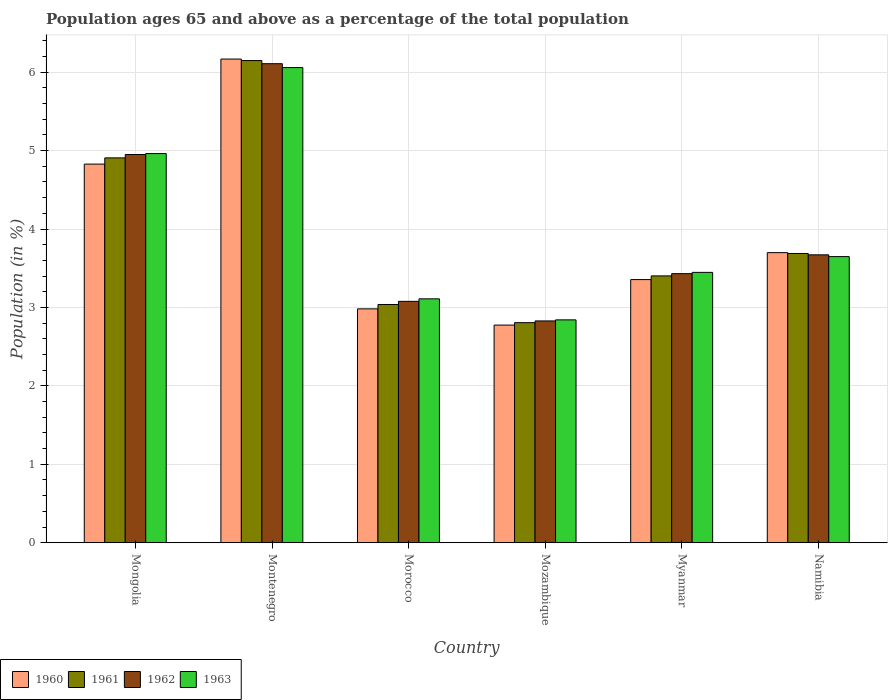How many different coloured bars are there?
Offer a terse response. 4. Are the number of bars per tick equal to the number of legend labels?
Provide a succinct answer. Yes. Are the number of bars on each tick of the X-axis equal?
Keep it short and to the point. Yes. How many bars are there on the 5th tick from the left?
Keep it short and to the point. 4. What is the label of the 6th group of bars from the left?
Ensure brevity in your answer.  Namibia. In how many cases, is the number of bars for a given country not equal to the number of legend labels?
Your answer should be very brief. 0. What is the percentage of the population ages 65 and above in 1962 in Namibia?
Your answer should be very brief. 3.67. Across all countries, what is the maximum percentage of the population ages 65 and above in 1961?
Give a very brief answer. 6.15. Across all countries, what is the minimum percentage of the population ages 65 and above in 1963?
Keep it short and to the point. 2.84. In which country was the percentage of the population ages 65 and above in 1963 maximum?
Offer a terse response. Montenegro. In which country was the percentage of the population ages 65 and above in 1961 minimum?
Your answer should be compact. Mozambique. What is the total percentage of the population ages 65 and above in 1961 in the graph?
Your response must be concise. 23.99. What is the difference between the percentage of the population ages 65 and above in 1962 in Mozambique and that in Myanmar?
Provide a succinct answer. -0.6. What is the difference between the percentage of the population ages 65 and above in 1961 in Morocco and the percentage of the population ages 65 and above in 1960 in Montenegro?
Ensure brevity in your answer.  -3.13. What is the average percentage of the population ages 65 and above in 1963 per country?
Offer a very short reply. 4.01. What is the difference between the percentage of the population ages 65 and above of/in 1960 and percentage of the population ages 65 and above of/in 1961 in Myanmar?
Make the answer very short. -0.05. In how many countries, is the percentage of the population ages 65 and above in 1962 greater than 5.2?
Your response must be concise. 1. What is the ratio of the percentage of the population ages 65 and above in 1962 in Mozambique to that in Namibia?
Your answer should be compact. 0.77. What is the difference between the highest and the second highest percentage of the population ages 65 and above in 1963?
Provide a short and direct response. -1.31. What is the difference between the highest and the lowest percentage of the population ages 65 and above in 1962?
Your answer should be very brief. 3.28. Is it the case that in every country, the sum of the percentage of the population ages 65 and above in 1960 and percentage of the population ages 65 and above in 1962 is greater than the sum of percentage of the population ages 65 and above in 1963 and percentage of the population ages 65 and above in 1961?
Your response must be concise. No. What does the 4th bar from the left in Mozambique represents?
Make the answer very short. 1963. Is it the case that in every country, the sum of the percentage of the population ages 65 and above in 1962 and percentage of the population ages 65 and above in 1960 is greater than the percentage of the population ages 65 and above in 1963?
Offer a very short reply. Yes. Are all the bars in the graph horizontal?
Make the answer very short. No. What is the difference between two consecutive major ticks on the Y-axis?
Offer a terse response. 1. Where does the legend appear in the graph?
Your answer should be very brief. Bottom left. How many legend labels are there?
Your response must be concise. 4. How are the legend labels stacked?
Provide a short and direct response. Horizontal. What is the title of the graph?
Your answer should be compact. Population ages 65 and above as a percentage of the total population. Does "2009" appear as one of the legend labels in the graph?
Provide a succinct answer. No. What is the label or title of the Y-axis?
Offer a very short reply. Population (in %). What is the Population (in %) in 1960 in Mongolia?
Offer a terse response. 4.83. What is the Population (in %) of 1961 in Mongolia?
Provide a succinct answer. 4.91. What is the Population (in %) in 1962 in Mongolia?
Ensure brevity in your answer.  4.95. What is the Population (in %) of 1963 in Mongolia?
Offer a terse response. 4.96. What is the Population (in %) in 1960 in Montenegro?
Offer a terse response. 6.17. What is the Population (in %) in 1961 in Montenegro?
Offer a very short reply. 6.15. What is the Population (in %) of 1962 in Montenegro?
Offer a terse response. 6.11. What is the Population (in %) in 1963 in Montenegro?
Offer a terse response. 6.06. What is the Population (in %) in 1960 in Morocco?
Your response must be concise. 2.98. What is the Population (in %) of 1961 in Morocco?
Your answer should be compact. 3.04. What is the Population (in %) of 1962 in Morocco?
Provide a short and direct response. 3.08. What is the Population (in %) in 1963 in Morocco?
Give a very brief answer. 3.11. What is the Population (in %) in 1960 in Mozambique?
Keep it short and to the point. 2.78. What is the Population (in %) of 1961 in Mozambique?
Make the answer very short. 2.81. What is the Population (in %) in 1962 in Mozambique?
Ensure brevity in your answer.  2.83. What is the Population (in %) of 1963 in Mozambique?
Offer a terse response. 2.84. What is the Population (in %) of 1960 in Myanmar?
Keep it short and to the point. 3.36. What is the Population (in %) in 1961 in Myanmar?
Provide a short and direct response. 3.4. What is the Population (in %) of 1962 in Myanmar?
Give a very brief answer. 3.43. What is the Population (in %) of 1963 in Myanmar?
Your answer should be compact. 3.45. What is the Population (in %) of 1960 in Namibia?
Offer a very short reply. 3.7. What is the Population (in %) in 1961 in Namibia?
Provide a succinct answer. 3.69. What is the Population (in %) in 1962 in Namibia?
Make the answer very short. 3.67. What is the Population (in %) in 1963 in Namibia?
Make the answer very short. 3.65. Across all countries, what is the maximum Population (in %) of 1960?
Offer a very short reply. 6.17. Across all countries, what is the maximum Population (in %) of 1961?
Your response must be concise. 6.15. Across all countries, what is the maximum Population (in %) of 1962?
Ensure brevity in your answer.  6.11. Across all countries, what is the maximum Population (in %) in 1963?
Offer a very short reply. 6.06. Across all countries, what is the minimum Population (in %) of 1960?
Offer a terse response. 2.78. Across all countries, what is the minimum Population (in %) in 1961?
Provide a succinct answer. 2.81. Across all countries, what is the minimum Population (in %) in 1962?
Your answer should be compact. 2.83. Across all countries, what is the minimum Population (in %) of 1963?
Keep it short and to the point. 2.84. What is the total Population (in %) in 1960 in the graph?
Provide a short and direct response. 23.81. What is the total Population (in %) of 1961 in the graph?
Your answer should be compact. 23.99. What is the total Population (in %) in 1962 in the graph?
Provide a short and direct response. 24.07. What is the total Population (in %) in 1963 in the graph?
Your answer should be compact. 24.07. What is the difference between the Population (in %) of 1960 in Mongolia and that in Montenegro?
Offer a terse response. -1.34. What is the difference between the Population (in %) of 1961 in Mongolia and that in Montenegro?
Give a very brief answer. -1.24. What is the difference between the Population (in %) in 1962 in Mongolia and that in Montenegro?
Your answer should be compact. -1.16. What is the difference between the Population (in %) of 1963 in Mongolia and that in Montenegro?
Ensure brevity in your answer.  -1.1. What is the difference between the Population (in %) in 1960 in Mongolia and that in Morocco?
Ensure brevity in your answer.  1.85. What is the difference between the Population (in %) in 1961 in Mongolia and that in Morocco?
Provide a short and direct response. 1.87. What is the difference between the Population (in %) in 1962 in Mongolia and that in Morocco?
Ensure brevity in your answer.  1.87. What is the difference between the Population (in %) in 1963 in Mongolia and that in Morocco?
Ensure brevity in your answer.  1.85. What is the difference between the Population (in %) in 1960 in Mongolia and that in Mozambique?
Give a very brief answer. 2.05. What is the difference between the Population (in %) of 1961 in Mongolia and that in Mozambique?
Keep it short and to the point. 2.1. What is the difference between the Population (in %) in 1962 in Mongolia and that in Mozambique?
Your answer should be compact. 2.12. What is the difference between the Population (in %) in 1963 in Mongolia and that in Mozambique?
Your answer should be very brief. 2.12. What is the difference between the Population (in %) of 1960 in Mongolia and that in Myanmar?
Offer a very short reply. 1.47. What is the difference between the Population (in %) of 1961 in Mongolia and that in Myanmar?
Make the answer very short. 1.5. What is the difference between the Population (in %) of 1962 in Mongolia and that in Myanmar?
Offer a terse response. 1.52. What is the difference between the Population (in %) in 1963 in Mongolia and that in Myanmar?
Provide a short and direct response. 1.51. What is the difference between the Population (in %) of 1960 in Mongolia and that in Namibia?
Make the answer very short. 1.13. What is the difference between the Population (in %) in 1961 in Mongolia and that in Namibia?
Offer a very short reply. 1.22. What is the difference between the Population (in %) in 1962 in Mongolia and that in Namibia?
Your answer should be compact. 1.28. What is the difference between the Population (in %) of 1963 in Mongolia and that in Namibia?
Offer a terse response. 1.31. What is the difference between the Population (in %) in 1960 in Montenegro and that in Morocco?
Your answer should be very brief. 3.19. What is the difference between the Population (in %) in 1961 in Montenegro and that in Morocco?
Your answer should be very brief. 3.11. What is the difference between the Population (in %) in 1962 in Montenegro and that in Morocco?
Give a very brief answer. 3.03. What is the difference between the Population (in %) of 1963 in Montenegro and that in Morocco?
Your response must be concise. 2.95. What is the difference between the Population (in %) of 1960 in Montenegro and that in Mozambique?
Provide a succinct answer. 3.39. What is the difference between the Population (in %) in 1961 in Montenegro and that in Mozambique?
Offer a terse response. 3.34. What is the difference between the Population (in %) of 1962 in Montenegro and that in Mozambique?
Provide a short and direct response. 3.28. What is the difference between the Population (in %) of 1963 in Montenegro and that in Mozambique?
Offer a terse response. 3.22. What is the difference between the Population (in %) of 1960 in Montenegro and that in Myanmar?
Your answer should be compact. 2.81. What is the difference between the Population (in %) in 1961 in Montenegro and that in Myanmar?
Keep it short and to the point. 2.75. What is the difference between the Population (in %) of 1962 in Montenegro and that in Myanmar?
Your answer should be very brief. 2.68. What is the difference between the Population (in %) of 1963 in Montenegro and that in Myanmar?
Make the answer very short. 2.61. What is the difference between the Population (in %) in 1960 in Montenegro and that in Namibia?
Your answer should be very brief. 2.47. What is the difference between the Population (in %) of 1961 in Montenegro and that in Namibia?
Provide a short and direct response. 2.46. What is the difference between the Population (in %) of 1962 in Montenegro and that in Namibia?
Make the answer very short. 2.44. What is the difference between the Population (in %) in 1963 in Montenegro and that in Namibia?
Offer a terse response. 2.41. What is the difference between the Population (in %) in 1960 in Morocco and that in Mozambique?
Ensure brevity in your answer.  0.21. What is the difference between the Population (in %) in 1961 in Morocco and that in Mozambique?
Keep it short and to the point. 0.23. What is the difference between the Population (in %) of 1962 in Morocco and that in Mozambique?
Offer a very short reply. 0.25. What is the difference between the Population (in %) in 1963 in Morocco and that in Mozambique?
Offer a terse response. 0.27. What is the difference between the Population (in %) in 1960 in Morocco and that in Myanmar?
Ensure brevity in your answer.  -0.37. What is the difference between the Population (in %) in 1961 in Morocco and that in Myanmar?
Provide a succinct answer. -0.36. What is the difference between the Population (in %) in 1962 in Morocco and that in Myanmar?
Make the answer very short. -0.35. What is the difference between the Population (in %) in 1963 in Morocco and that in Myanmar?
Offer a very short reply. -0.34. What is the difference between the Population (in %) of 1960 in Morocco and that in Namibia?
Ensure brevity in your answer.  -0.72. What is the difference between the Population (in %) of 1961 in Morocco and that in Namibia?
Your response must be concise. -0.65. What is the difference between the Population (in %) of 1962 in Morocco and that in Namibia?
Your response must be concise. -0.59. What is the difference between the Population (in %) in 1963 in Morocco and that in Namibia?
Offer a terse response. -0.54. What is the difference between the Population (in %) in 1960 in Mozambique and that in Myanmar?
Give a very brief answer. -0.58. What is the difference between the Population (in %) of 1961 in Mozambique and that in Myanmar?
Give a very brief answer. -0.6. What is the difference between the Population (in %) of 1962 in Mozambique and that in Myanmar?
Give a very brief answer. -0.6. What is the difference between the Population (in %) in 1963 in Mozambique and that in Myanmar?
Keep it short and to the point. -0.61. What is the difference between the Population (in %) in 1960 in Mozambique and that in Namibia?
Provide a succinct answer. -0.92. What is the difference between the Population (in %) in 1961 in Mozambique and that in Namibia?
Provide a succinct answer. -0.88. What is the difference between the Population (in %) of 1962 in Mozambique and that in Namibia?
Keep it short and to the point. -0.84. What is the difference between the Population (in %) of 1963 in Mozambique and that in Namibia?
Make the answer very short. -0.81. What is the difference between the Population (in %) of 1960 in Myanmar and that in Namibia?
Your answer should be very brief. -0.34. What is the difference between the Population (in %) of 1961 in Myanmar and that in Namibia?
Give a very brief answer. -0.29. What is the difference between the Population (in %) of 1962 in Myanmar and that in Namibia?
Offer a very short reply. -0.24. What is the difference between the Population (in %) in 1963 in Myanmar and that in Namibia?
Ensure brevity in your answer.  -0.2. What is the difference between the Population (in %) of 1960 in Mongolia and the Population (in %) of 1961 in Montenegro?
Make the answer very short. -1.32. What is the difference between the Population (in %) of 1960 in Mongolia and the Population (in %) of 1962 in Montenegro?
Make the answer very short. -1.28. What is the difference between the Population (in %) of 1960 in Mongolia and the Population (in %) of 1963 in Montenegro?
Provide a succinct answer. -1.23. What is the difference between the Population (in %) of 1961 in Mongolia and the Population (in %) of 1962 in Montenegro?
Ensure brevity in your answer.  -1.2. What is the difference between the Population (in %) in 1961 in Mongolia and the Population (in %) in 1963 in Montenegro?
Make the answer very short. -1.15. What is the difference between the Population (in %) in 1962 in Mongolia and the Population (in %) in 1963 in Montenegro?
Give a very brief answer. -1.11. What is the difference between the Population (in %) of 1960 in Mongolia and the Population (in %) of 1961 in Morocco?
Provide a short and direct response. 1.79. What is the difference between the Population (in %) in 1960 in Mongolia and the Population (in %) in 1962 in Morocco?
Offer a terse response. 1.75. What is the difference between the Population (in %) in 1960 in Mongolia and the Population (in %) in 1963 in Morocco?
Provide a short and direct response. 1.72. What is the difference between the Population (in %) in 1961 in Mongolia and the Population (in %) in 1962 in Morocco?
Your answer should be compact. 1.83. What is the difference between the Population (in %) of 1961 in Mongolia and the Population (in %) of 1963 in Morocco?
Provide a succinct answer. 1.8. What is the difference between the Population (in %) of 1962 in Mongolia and the Population (in %) of 1963 in Morocco?
Ensure brevity in your answer.  1.84. What is the difference between the Population (in %) in 1960 in Mongolia and the Population (in %) in 1961 in Mozambique?
Give a very brief answer. 2.02. What is the difference between the Population (in %) in 1960 in Mongolia and the Population (in %) in 1962 in Mozambique?
Offer a very short reply. 2. What is the difference between the Population (in %) in 1960 in Mongolia and the Population (in %) in 1963 in Mozambique?
Your answer should be very brief. 1.99. What is the difference between the Population (in %) in 1961 in Mongolia and the Population (in %) in 1962 in Mozambique?
Make the answer very short. 2.08. What is the difference between the Population (in %) in 1961 in Mongolia and the Population (in %) in 1963 in Mozambique?
Offer a terse response. 2.07. What is the difference between the Population (in %) in 1962 in Mongolia and the Population (in %) in 1963 in Mozambique?
Offer a very short reply. 2.11. What is the difference between the Population (in %) in 1960 in Mongolia and the Population (in %) in 1961 in Myanmar?
Offer a very short reply. 1.43. What is the difference between the Population (in %) in 1960 in Mongolia and the Population (in %) in 1962 in Myanmar?
Make the answer very short. 1.4. What is the difference between the Population (in %) in 1960 in Mongolia and the Population (in %) in 1963 in Myanmar?
Provide a short and direct response. 1.38. What is the difference between the Population (in %) of 1961 in Mongolia and the Population (in %) of 1962 in Myanmar?
Offer a terse response. 1.48. What is the difference between the Population (in %) of 1961 in Mongolia and the Population (in %) of 1963 in Myanmar?
Offer a terse response. 1.46. What is the difference between the Population (in %) of 1962 in Mongolia and the Population (in %) of 1963 in Myanmar?
Make the answer very short. 1.5. What is the difference between the Population (in %) in 1960 in Mongolia and the Population (in %) in 1961 in Namibia?
Keep it short and to the point. 1.14. What is the difference between the Population (in %) of 1960 in Mongolia and the Population (in %) of 1962 in Namibia?
Keep it short and to the point. 1.16. What is the difference between the Population (in %) in 1960 in Mongolia and the Population (in %) in 1963 in Namibia?
Your answer should be very brief. 1.18. What is the difference between the Population (in %) of 1961 in Mongolia and the Population (in %) of 1962 in Namibia?
Provide a succinct answer. 1.24. What is the difference between the Population (in %) in 1961 in Mongolia and the Population (in %) in 1963 in Namibia?
Offer a terse response. 1.26. What is the difference between the Population (in %) of 1962 in Mongolia and the Population (in %) of 1963 in Namibia?
Make the answer very short. 1.3. What is the difference between the Population (in %) in 1960 in Montenegro and the Population (in %) in 1961 in Morocco?
Offer a very short reply. 3.13. What is the difference between the Population (in %) of 1960 in Montenegro and the Population (in %) of 1962 in Morocco?
Offer a terse response. 3.09. What is the difference between the Population (in %) of 1960 in Montenegro and the Population (in %) of 1963 in Morocco?
Your answer should be compact. 3.06. What is the difference between the Population (in %) of 1961 in Montenegro and the Population (in %) of 1962 in Morocco?
Provide a short and direct response. 3.07. What is the difference between the Population (in %) of 1961 in Montenegro and the Population (in %) of 1963 in Morocco?
Your answer should be compact. 3.04. What is the difference between the Population (in %) in 1962 in Montenegro and the Population (in %) in 1963 in Morocco?
Provide a short and direct response. 3. What is the difference between the Population (in %) of 1960 in Montenegro and the Population (in %) of 1961 in Mozambique?
Your response must be concise. 3.36. What is the difference between the Population (in %) in 1960 in Montenegro and the Population (in %) in 1962 in Mozambique?
Make the answer very short. 3.34. What is the difference between the Population (in %) in 1960 in Montenegro and the Population (in %) in 1963 in Mozambique?
Offer a terse response. 3.33. What is the difference between the Population (in %) of 1961 in Montenegro and the Population (in %) of 1962 in Mozambique?
Make the answer very short. 3.32. What is the difference between the Population (in %) of 1961 in Montenegro and the Population (in %) of 1963 in Mozambique?
Your answer should be compact. 3.31. What is the difference between the Population (in %) of 1962 in Montenegro and the Population (in %) of 1963 in Mozambique?
Your response must be concise. 3.27. What is the difference between the Population (in %) of 1960 in Montenegro and the Population (in %) of 1961 in Myanmar?
Provide a succinct answer. 2.77. What is the difference between the Population (in %) in 1960 in Montenegro and the Population (in %) in 1962 in Myanmar?
Provide a succinct answer. 2.74. What is the difference between the Population (in %) of 1960 in Montenegro and the Population (in %) of 1963 in Myanmar?
Your answer should be very brief. 2.72. What is the difference between the Population (in %) in 1961 in Montenegro and the Population (in %) in 1962 in Myanmar?
Provide a short and direct response. 2.72. What is the difference between the Population (in %) of 1961 in Montenegro and the Population (in %) of 1963 in Myanmar?
Your answer should be very brief. 2.7. What is the difference between the Population (in %) in 1962 in Montenegro and the Population (in %) in 1963 in Myanmar?
Provide a short and direct response. 2.66. What is the difference between the Population (in %) in 1960 in Montenegro and the Population (in %) in 1961 in Namibia?
Ensure brevity in your answer.  2.48. What is the difference between the Population (in %) of 1960 in Montenegro and the Population (in %) of 1962 in Namibia?
Give a very brief answer. 2.5. What is the difference between the Population (in %) of 1960 in Montenegro and the Population (in %) of 1963 in Namibia?
Your answer should be very brief. 2.52. What is the difference between the Population (in %) of 1961 in Montenegro and the Population (in %) of 1962 in Namibia?
Provide a succinct answer. 2.48. What is the difference between the Population (in %) in 1961 in Montenegro and the Population (in %) in 1963 in Namibia?
Your response must be concise. 2.5. What is the difference between the Population (in %) in 1962 in Montenegro and the Population (in %) in 1963 in Namibia?
Offer a terse response. 2.46. What is the difference between the Population (in %) of 1960 in Morocco and the Population (in %) of 1961 in Mozambique?
Provide a short and direct response. 0.18. What is the difference between the Population (in %) in 1960 in Morocco and the Population (in %) in 1962 in Mozambique?
Offer a terse response. 0.15. What is the difference between the Population (in %) of 1960 in Morocco and the Population (in %) of 1963 in Mozambique?
Your response must be concise. 0.14. What is the difference between the Population (in %) in 1961 in Morocco and the Population (in %) in 1962 in Mozambique?
Give a very brief answer. 0.21. What is the difference between the Population (in %) in 1961 in Morocco and the Population (in %) in 1963 in Mozambique?
Your response must be concise. 0.2. What is the difference between the Population (in %) in 1962 in Morocco and the Population (in %) in 1963 in Mozambique?
Give a very brief answer. 0.24. What is the difference between the Population (in %) of 1960 in Morocco and the Population (in %) of 1961 in Myanmar?
Your answer should be compact. -0.42. What is the difference between the Population (in %) in 1960 in Morocco and the Population (in %) in 1962 in Myanmar?
Give a very brief answer. -0.45. What is the difference between the Population (in %) of 1960 in Morocco and the Population (in %) of 1963 in Myanmar?
Provide a succinct answer. -0.47. What is the difference between the Population (in %) in 1961 in Morocco and the Population (in %) in 1962 in Myanmar?
Make the answer very short. -0.39. What is the difference between the Population (in %) in 1961 in Morocco and the Population (in %) in 1963 in Myanmar?
Provide a succinct answer. -0.41. What is the difference between the Population (in %) in 1962 in Morocco and the Population (in %) in 1963 in Myanmar?
Keep it short and to the point. -0.37. What is the difference between the Population (in %) in 1960 in Morocco and the Population (in %) in 1961 in Namibia?
Your answer should be very brief. -0.71. What is the difference between the Population (in %) of 1960 in Morocco and the Population (in %) of 1962 in Namibia?
Keep it short and to the point. -0.69. What is the difference between the Population (in %) of 1960 in Morocco and the Population (in %) of 1963 in Namibia?
Give a very brief answer. -0.67. What is the difference between the Population (in %) of 1961 in Morocco and the Population (in %) of 1962 in Namibia?
Make the answer very short. -0.63. What is the difference between the Population (in %) of 1961 in Morocco and the Population (in %) of 1963 in Namibia?
Keep it short and to the point. -0.61. What is the difference between the Population (in %) in 1962 in Morocco and the Population (in %) in 1963 in Namibia?
Your answer should be compact. -0.57. What is the difference between the Population (in %) in 1960 in Mozambique and the Population (in %) in 1961 in Myanmar?
Provide a succinct answer. -0.63. What is the difference between the Population (in %) of 1960 in Mozambique and the Population (in %) of 1962 in Myanmar?
Keep it short and to the point. -0.66. What is the difference between the Population (in %) in 1960 in Mozambique and the Population (in %) in 1963 in Myanmar?
Provide a short and direct response. -0.67. What is the difference between the Population (in %) in 1961 in Mozambique and the Population (in %) in 1962 in Myanmar?
Offer a very short reply. -0.62. What is the difference between the Population (in %) of 1961 in Mozambique and the Population (in %) of 1963 in Myanmar?
Offer a terse response. -0.64. What is the difference between the Population (in %) in 1962 in Mozambique and the Population (in %) in 1963 in Myanmar?
Your answer should be compact. -0.62. What is the difference between the Population (in %) in 1960 in Mozambique and the Population (in %) in 1961 in Namibia?
Give a very brief answer. -0.91. What is the difference between the Population (in %) of 1960 in Mozambique and the Population (in %) of 1962 in Namibia?
Give a very brief answer. -0.9. What is the difference between the Population (in %) in 1960 in Mozambique and the Population (in %) in 1963 in Namibia?
Give a very brief answer. -0.87. What is the difference between the Population (in %) in 1961 in Mozambique and the Population (in %) in 1962 in Namibia?
Ensure brevity in your answer.  -0.86. What is the difference between the Population (in %) of 1961 in Mozambique and the Population (in %) of 1963 in Namibia?
Your response must be concise. -0.84. What is the difference between the Population (in %) of 1962 in Mozambique and the Population (in %) of 1963 in Namibia?
Your answer should be compact. -0.82. What is the difference between the Population (in %) of 1960 in Myanmar and the Population (in %) of 1961 in Namibia?
Keep it short and to the point. -0.33. What is the difference between the Population (in %) in 1960 in Myanmar and the Population (in %) in 1962 in Namibia?
Give a very brief answer. -0.32. What is the difference between the Population (in %) of 1960 in Myanmar and the Population (in %) of 1963 in Namibia?
Your answer should be very brief. -0.29. What is the difference between the Population (in %) of 1961 in Myanmar and the Population (in %) of 1962 in Namibia?
Give a very brief answer. -0.27. What is the difference between the Population (in %) of 1961 in Myanmar and the Population (in %) of 1963 in Namibia?
Give a very brief answer. -0.25. What is the difference between the Population (in %) of 1962 in Myanmar and the Population (in %) of 1963 in Namibia?
Your response must be concise. -0.22. What is the average Population (in %) of 1960 per country?
Provide a succinct answer. 3.97. What is the average Population (in %) of 1961 per country?
Your answer should be very brief. 4. What is the average Population (in %) in 1962 per country?
Offer a terse response. 4.01. What is the average Population (in %) of 1963 per country?
Make the answer very short. 4.01. What is the difference between the Population (in %) of 1960 and Population (in %) of 1961 in Mongolia?
Provide a short and direct response. -0.08. What is the difference between the Population (in %) of 1960 and Population (in %) of 1962 in Mongolia?
Offer a very short reply. -0.12. What is the difference between the Population (in %) in 1960 and Population (in %) in 1963 in Mongolia?
Provide a succinct answer. -0.13. What is the difference between the Population (in %) of 1961 and Population (in %) of 1962 in Mongolia?
Make the answer very short. -0.04. What is the difference between the Population (in %) in 1961 and Population (in %) in 1963 in Mongolia?
Give a very brief answer. -0.05. What is the difference between the Population (in %) of 1962 and Population (in %) of 1963 in Mongolia?
Offer a terse response. -0.01. What is the difference between the Population (in %) in 1960 and Population (in %) in 1961 in Montenegro?
Offer a very short reply. 0.02. What is the difference between the Population (in %) of 1960 and Population (in %) of 1962 in Montenegro?
Your answer should be compact. 0.06. What is the difference between the Population (in %) in 1960 and Population (in %) in 1963 in Montenegro?
Your answer should be compact. 0.11. What is the difference between the Population (in %) in 1961 and Population (in %) in 1963 in Montenegro?
Your answer should be very brief. 0.09. What is the difference between the Population (in %) in 1962 and Population (in %) in 1963 in Montenegro?
Keep it short and to the point. 0.05. What is the difference between the Population (in %) of 1960 and Population (in %) of 1961 in Morocco?
Ensure brevity in your answer.  -0.06. What is the difference between the Population (in %) of 1960 and Population (in %) of 1962 in Morocco?
Provide a short and direct response. -0.1. What is the difference between the Population (in %) in 1960 and Population (in %) in 1963 in Morocco?
Your response must be concise. -0.13. What is the difference between the Population (in %) in 1961 and Population (in %) in 1962 in Morocco?
Your response must be concise. -0.04. What is the difference between the Population (in %) of 1961 and Population (in %) of 1963 in Morocco?
Your answer should be very brief. -0.07. What is the difference between the Population (in %) in 1962 and Population (in %) in 1963 in Morocco?
Ensure brevity in your answer.  -0.03. What is the difference between the Population (in %) of 1960 and Population (in %) of 1961 in Mozambique?
Your answer should be very brief. -0.03. What is the difference between the Population (in %) of 1960 and Population (in %) of 1962 in Mozambique?
Offer a very short reply. -0.05. What is the difference between the Population (in %) in 1960 and Population (in %) in 1963 in Mozambique?
Provide a succinct answer. -0.07. What is the difference between the Population (in %) in 1961 and Population (in %) in 1962 in Mozambique?
Keep it short and to the point. -0.02. What is the difference between the Population (in %) in 1961 and Population (in %) in 1963 in Mozambique?
Make the answer very short. -0.04. What is the difference between the Population (in %) in 1962 and Population (in %) in 1963 in Mozambique?
Make the answer very short. -0.01. What is the difference between the Population (in %) in 1960 and Population (in %) in 1961 in Myanmar?
Provide a succinct answer. -0.05. What is the difference between the Population (in %) of 1960 and Population (in %) of 1962 in Myanmar?
Give a very brief answer. -0.08. What is the difference between the Population (in %) in 1960 and Population (in %) in 1963 in Myanmar?
Make the answer very short. -0.09. What is the difference between the Population (in %) in 1961 and Population (in %) in 1962 in Myanmar?
Your answer should be compact. -0.03. What is the difference between the Population (in %) of 1961 and Population (in %) of 1963 in Myanmar?
Your answer should be very brief. -0.04. What is the difference between the Population (in %) of 1962 and Population (in %) of 1963 in Myanmar?
Make the answer very short. -0.02. What is the difference between the Population (in %) in 1960 and Population (in %) in 1961 in Namibia?
Provide a succinct answer. 0.01. What is the difference between the Population (in %) in 1960 and Population (in %) in 1962 in Namibia?
Your answer should be very brief. 0.03. What is the difference between the Population (in %) of 1960 and Population (in %) of 1963 in Namibia?
Your answer should be compact. 0.05. What is the difference between the Population (in %) of 1961 and Population (in %) of 1962 in Namibia?
Offer a terse response. 0.02. What is the difference between the Population (in %) in 1961 and Population (in %) in 1963 in Namibia?
Your response must be concise. 0.04. What is the difference between the Population (in %) of 1962 and Population (in %) of 1963 in Namibia?
Your response must be concise. 0.02. What is the ratio of the Population (in %) in 1960 in Mongolia to that in Montenegro?
Provide a succinct answer. 0.78. What is the ratio of the Population (in %) in 1961 in Mongolia to that in Montenegro?
Provide a succinct answer. 0.8. What is the ratio of the Population (in %) of 1962 in Mongolia to that in Montenegro?
Your answer should be very brief. 0.81. What is the ratio of the Population (in %) of 1963 in Mongolia to that in Montenegro?
Offer a very short reply. 0.82. What is the ratio of the Population (in %) of 1960 in Mongolia to that in Morocco?
Your answer should be very brief. 1.62. What is the ratio of the Population (in %) in 1961 in Mongolia to that in Morocco?
Ensure brevity in your answer.  1.62. What is the ratio of the Population (in %) of 1962 in Mongolia to that in Morocco?
Your answer should be compact. 1.61. What is the ratio of the Population (in %) in 1963 in Mongolia to that in Morocco?
Keep it short and to the point. 1.6. What is the ratio of the Population (in %) of 1960 in Mongolia to that in Mozambique?
Your answer should be very brief. 1.74. What is the ratio of the Population (in %) in 1961 in Mongolia to that in Mozambique?
Offer a very short reply. 1.75. What is the ratio of the Population (in %) of 1962 in Mongolia to that in Mozambique?
Give a very brief answer. 1.75. What is the ratio of the Population (in %) in 1963 in Mongolia to that in Mozambique?
Ensure brevity in your answer.  1.75. What is the ratio of the Population (in %) in 1960 in Mongolia to that in Myanmar?
Offer a very short reply. 1.44. What is the ratio of the Population (in %) in 1961 in Mongolia to that in Myanmar?
Give a very brief answer. 1.44. What is the ratio of the Population (in %) in 1962 in Mongolia to that in Myanmar?
Provide a short and direct response. 1.44. What is the ratio of the Population (in %) of 1963 in Mongolia to that in Myanmar?
Provide a succinct answer. 1.44. What is the ratio of the Population (in %) of 1960 in Mongolia to that in Namibia?
Your response must be concise. 1.31. What is the ratio of the Population (in %) of 1961 in Mongolia to that in Namibia?
Your answer should be compact. 1.33. What is the ratio of the Population (in %) in 1962 in Mongolia to that in Namibia?
Keep it short and to the point. 1.35. What is the ratio of the Population (in %) in 1963 in Mongolia to that in Namibia?
Give a very brief answer. 1.36. What is the ratio of the Population (in %) of 1960 in Montenegro to that in Morocco?
Offer a very short reply. 2.07. What is the ratio of the Population (in %) of 1961 in Montenegro to that in Morocco?
Give a very brief answer. 2.02. What is the ratio of the Population (in %) in 1962 in Montenegro to that in Morocco?
Ensure brevity in your answer.  1.98. What is the ratio of the Population (in %) of 1963 in Montenegro to that in Morocco?
Your answer should be compact. 1.95. What is the ratio of the Population (in %) of 1960 in Montenegro to that in Mozambique?
Your answer should be very brief. 2.22. What is the ratio of the Population (in %) of 1961 in Montenegro to that in Mozambique?
Provide a succinct answer. 2.19. What is the ratio of the Population (in %) of 1962 in Montenegro to that in Mozambique?
Keep it short and to the point. 2.16. What is the ratio of the Population (in %) in 1963 in Montenegro to that in Mozambique?
Ensure brevity in your answer.  2.13. What is the ratio of the Population (in %) of 1960 in Montenegro to that in Myanmar?
Offer a terse response. 1.84. What is the ratio of the Population (in %) in 1961 in Montenegro to that in Myanmar?
Keep it short and to the point. 1.81. What is the ratio of the Population (in %) in 1962 in Montenegro to that in Myanmar?
Your response must be concise. 1.78. What is the ratio of the Population (in %) of 1963 in Montenegro to that in Myanmar?
Make the answer very short. 1.76. What is the ratio of the Population (in %) of 1960 in Montenegro to that in Namibia?
Your answer should be compact. 1.67. What is the ratio of the Population (in %) of 1961 in Montenegro to that in Namibia?
Provide a succinct answer. 1.67. What is the ratio of the Population (in %) of 1962 in Montenegro to that in Namibia?
Ensure brevity in your answer.  1.66. What is the ratio of the Population (in %) in 1963 in Montenegro to that in Namibia?
Your answer should be compact. 1.66. What is the ratio of the Population (in %) in 1960 in Morocco to that in Mozambique?
Provide a short and direct response. 1.07. What is the ratio of the Population (in %) of 1961 in Morocco to that in Mozambique?
Offer a terse response. 1.08. What is the ratio of the Population (in %) in 1962 in Morocco to that in Mozambique?
Offer a very short reply. 1.09. What is the ratio of the Population (in %) in 1963 in Morocco to that in Mozambique?
Your answer should be very brief. 1.09. What is the ratio of the Population (in %) in 1960 in Morocco to that in Myanmar?
Your response must be concise. 0.89. What is the ratio of the Population (in %) of 1961 in Morocco to that in Myanmar?
Offer a very short reply. 0.89. What is the ratio of the Population (in %) in 1962 in Morocco to that in Myanmar?
Provide a short and direct response. 0.9. What is the ratio of the Population (in %) in 1963 in Morocco to that in Myanmar?
Your response must be concise. 0.9. What is the ratio of the Population (in %) of 1960 in Morocco to that in Namibia?
Your answer should be very brief. 0.81. What is the ratio of the Population (in %) in 1961 in Morocco to that in Namibia?
Ensure brevity in your answer.  0.82. What is the ratio of the Population (in %) of 1962 in Morocco to that in Namibia?
Provide a succinct answer. 0.84. What is the ratio of the Population (in %) in 1963 in Morocco to that in Namibia?
Ensure brevity in your answer.  0.85. What is the ratio of the Population (in %) of 1960 in Mozambique to that in Myanmar?
Your response must be concise. 0.83. What is the ratio of the Population (in %) in 1961 in Mozambique to that in Myanmar?
Your response must be concise. 0.82. What is the ratio of the Population (in %) in 1962 in Mozambique to that in Myanmar?
Keep it short and to the point. 0.82. What is the ratio of the Population (in %) of 1963 in Mozambique to that in Myanmar?
Your answer should be very brief. 0.82. What is the ratio of the Population (in %) of 1960 in Mozambique to that in Namibia?
Ensure brevity in your answer.  0.75. What is the ratio of the Population (in %) in 1961 in Mozambique to that in Namibia?
Your answer should be very brief. 0.76. What is the ratio of the Population (in %) of 1962 in Mozambique to that in Namibia?
Your answer should be very brief. 0.77. What is the ratio of the Population (in %) of 1963 in Mozambique to that in Namibia?
Offer a very short reply. 0.78. What is the ratio of the Population (in %) of 1960 in Myanmar to that in Namibia?
Make the answer very short. 0.91. What is the ratio of the Population (in %) of 1961 in Myanmar to that in Namibia?
Make the answer very short. 0.92. What is the ratio of the Population (in %) of 1962 in Myanmar to that in Namibia?
Provide a succinct answer. 0.93. What is the ratio of the Population (in %) in 1963 in Myanmar to that in Namibia?
Offer a terse response. 0.94. What is the difference between the highest and the second highest Population (in %) in 1960?
Offer a terse response. 1.34. What is the difference between the highest and the second highest Population (in %) of 1961?
Keep it short and to the point. 1.24. What is the difference between the highest and the second highest Population (in %) of 1962?
Provide a short and direct response. 1.16. What is the difference between the highest and the second highest Population (in %) in 1963?
Ensure brevity in your answer.  1.1. What is the difference between the highest and the lowest Population (in %) of 1960?
Your answer should be very brief. 3.39. What is the difference between the highest and the lowest Population (in %) in 1961?
Give a very brief answer. 3.34. What is the difference between the highest and the lowest Population (in %) of 1962?
Your answer should be compact. 3.28. What is the difference between the highest and the lowest Population (in %) in 1963?
Your response must be concise. 3.22. 